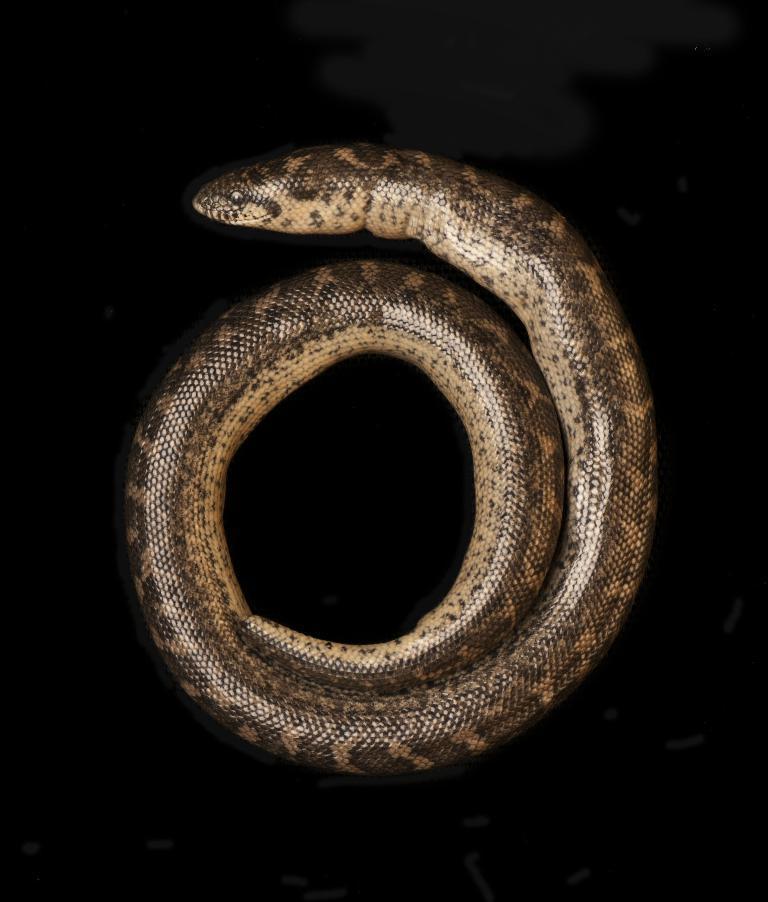How would you summarize this image in a sentence or two? Here in this picture we can see a snake present over there. 